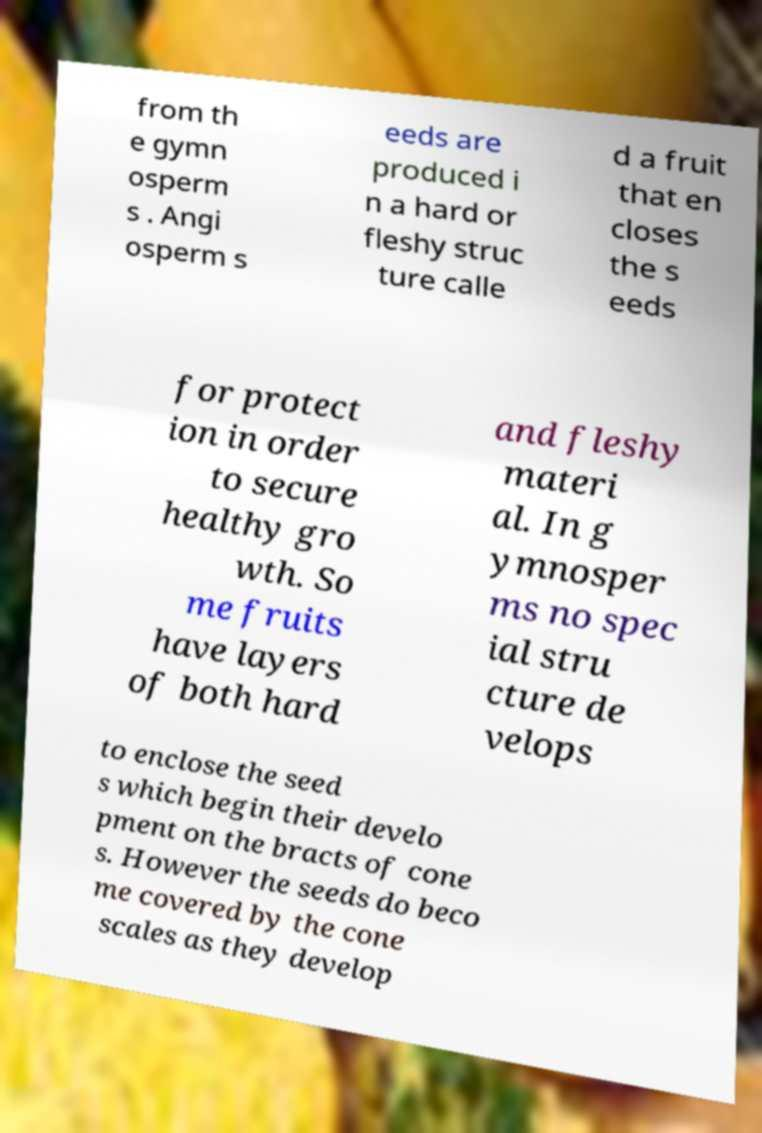For documentation purposes, I need the text within this image transcribed. Could you provide that? from th e gymn osperm s . Angi osperm s eeds are produced i n a hard or fleshy struc ture calle d a fruit that en closes the s eeds for protect ion in order to secure healthy gro wth. So me fruits have layers of both hard and fleshy materi al. In g ymnosper ms no spec ial stru cture de velops to enclose the seed s which begin their develo pment on the bracts of cone s. However the seeds do beco me covered by the cone scales as they develop 